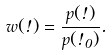Convert formula to latex. <formula><loc_0><loc_0><loc_500><loc_500>w ( \omega ) = \frac { p ( \omega ) } { p ( \omega _ { 0 } ) } .</formula> 